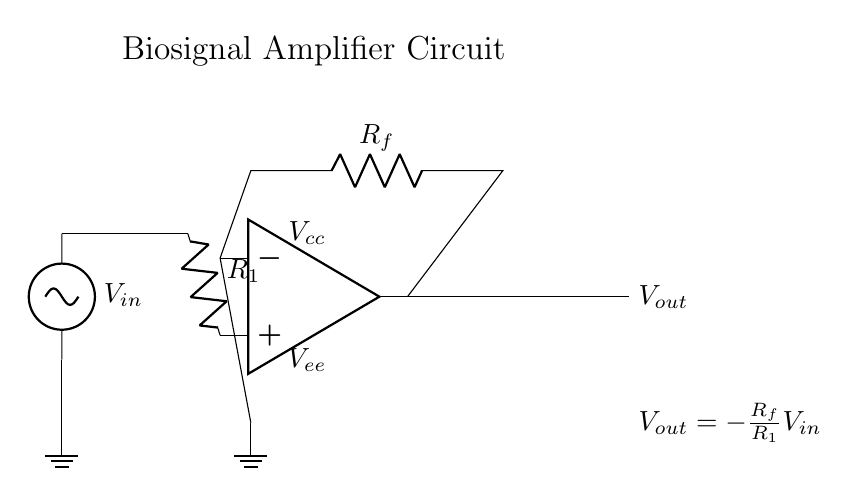What is the input voltage in this circuit? The input voltage is denoted as V_in, which is the voltage signal applied to the non-inverting terminal of the operational amplifier.
Answer: V_in What is the resistor connected to the input labeled as? The resistor connected to the input is labeled as R_1, which is part of the input resistor network involved in determining the gain of the amplifier.
Answer: R_1 What is the configuration used in this op-amp circuit? This circuit is configured as an inverting amplifier because the output is connected to the inverting terminal and the input is applied to the non-inverting terminal.
Answer: Inverting What is the relationship between the output voltage and the input voltage? The output voltage V_out is expressed by the equation V_out = - (R_f / R_1) * V_in, which indicates that the output voltage is inversely proportional to the input voltage, magnified by the resistor ratio.
Answer: V_out = - (R_f / R_1) * V_in What does R_f represent in this circuit? R_f represents the feedback resistor that connects the output of the op-amp back to the inverting terminal, allowing for feedback that stabilizes the gain of the amplifier.
Answer: R_f What are V_cc and V_ee in this diagram? V_cc and V_ee are the positive and negative supply voltages to the operational amplifier, respectively, providing the necessary operating conditions for the op-amp.
Answer: V_cc and V_ee 